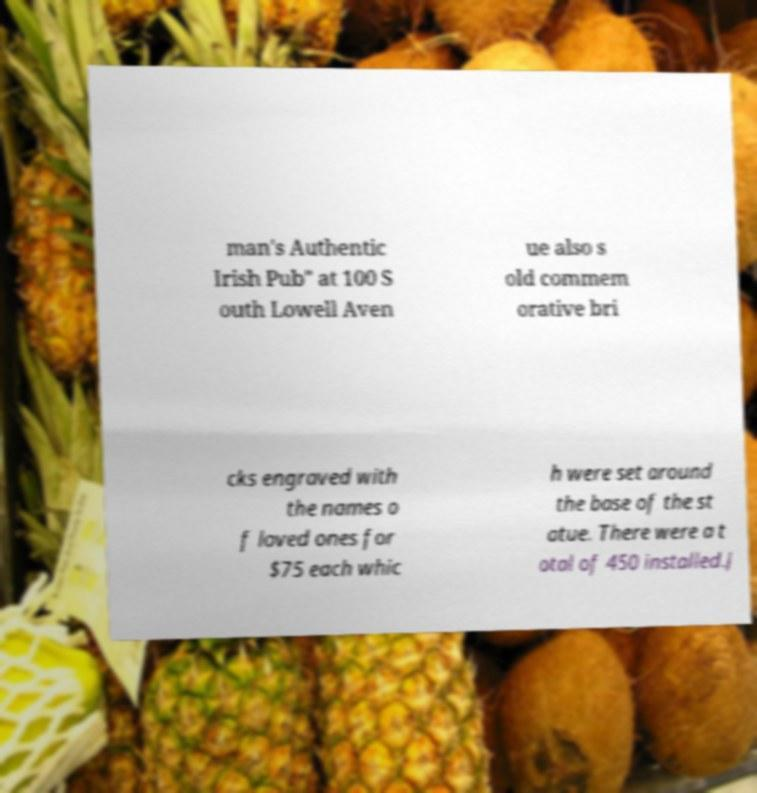What messages or text are displayed in this image? I need them in a readable, typed format. man's Authentic Irish Pub" at 100 S outh Lowell Aven ue also s old commem orative bri cks engraved with the names o f loved ones for $75 each whic h were set around the base of the st atue. There were a t otal of 450 installed.J 